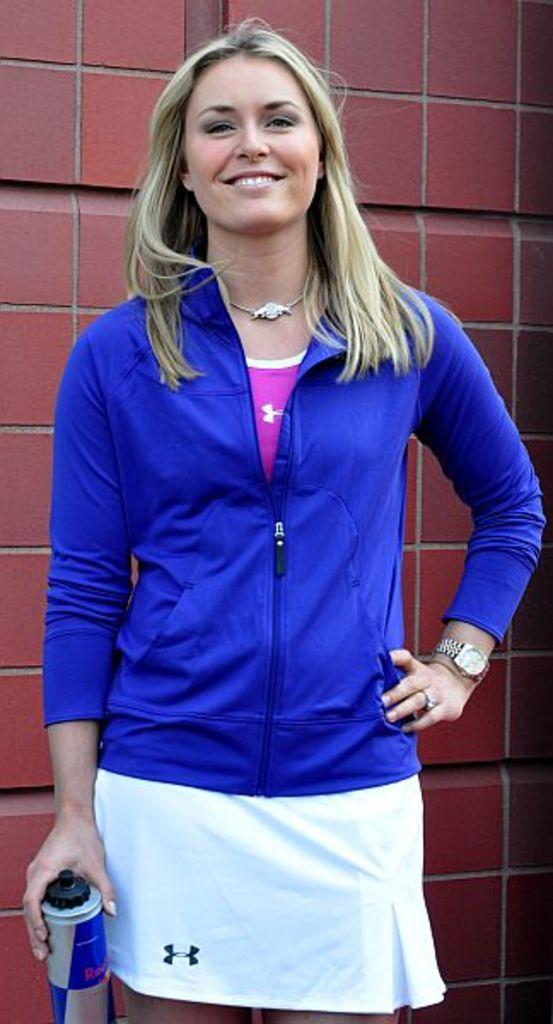Who is present in the image? There is a woman in the image. What is the woman wearing? The woman is wearing a jacket. What is the woman holding in her hand? The woman is holding a bottle in her hand. What is the woman's facial expression? The woman is smiling. What can be seen in the background of the image? There is a brick wall in the background of the image. What type of selection process is taking place in the field behind the woman? There is no field or selection process present in the image; it features a woman in front of a brick wall. 